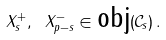<formula> <loc_0><loc_0><loc_500><loc_500>X _ { s } ^ { + } , \ X _ { p - s } ^ { - } \in \text {obj} ( \mathcal { C } _ { s } ) \, .</formula> 